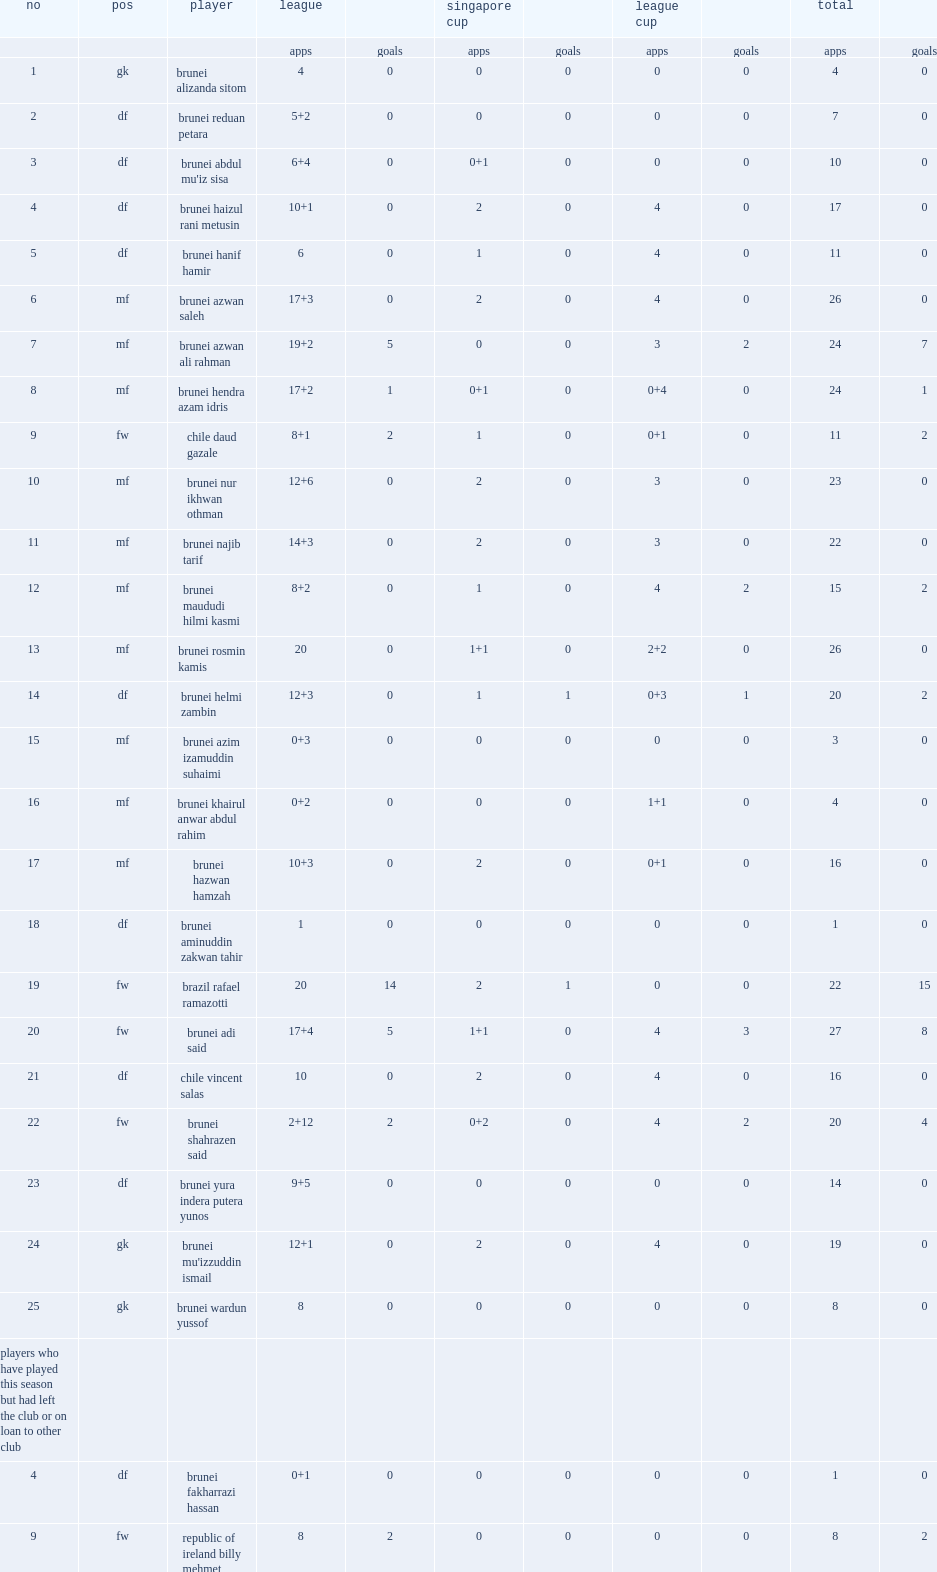List the matches that the club will compete in. League singapore cup league cup. 